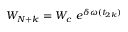<formula> <loc_0><loc_0><loc_500><loc_500>W _ { N + k } = W _ { c } \ e ^ { \delta \omega ( t _ { 2 k } ) }</formula> 